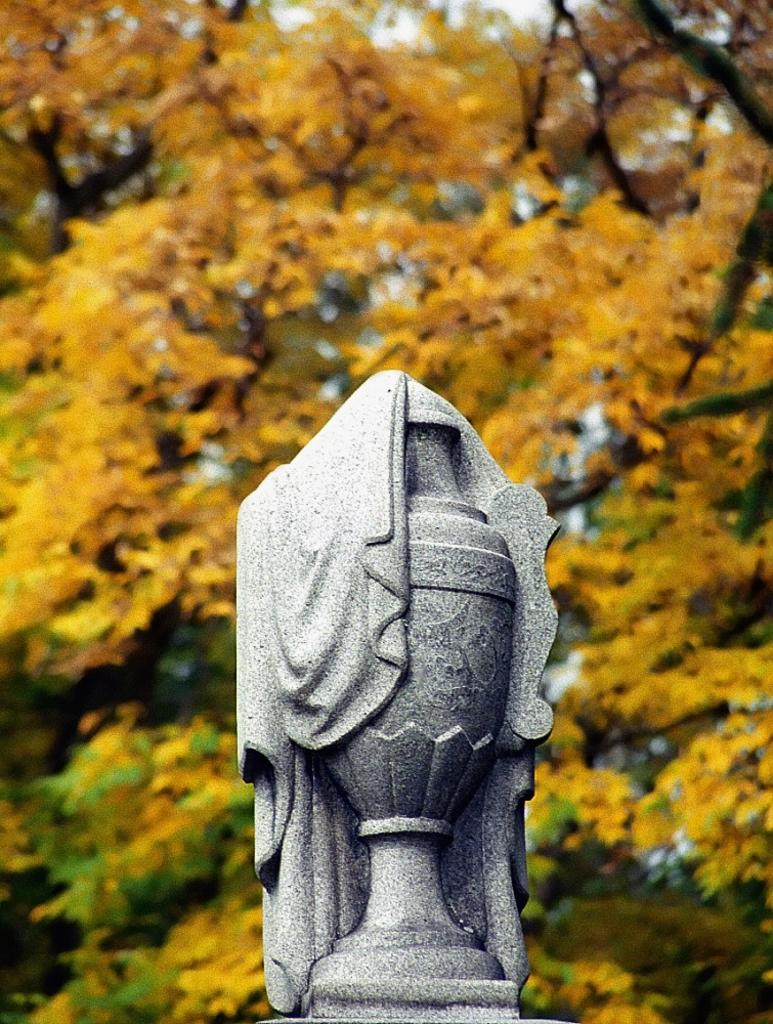What is the main subject in the foreground of the image? There is a statue in the foreground of the image. What can be seen in the background of the image? There are trees visible in the background of the image. What is visible at the top of the image? The sky is visible at the top of the image. What type of bread is being read by the statue in the image? There is no bread or reading activity present in the image; it features a statue and trees in the background. 